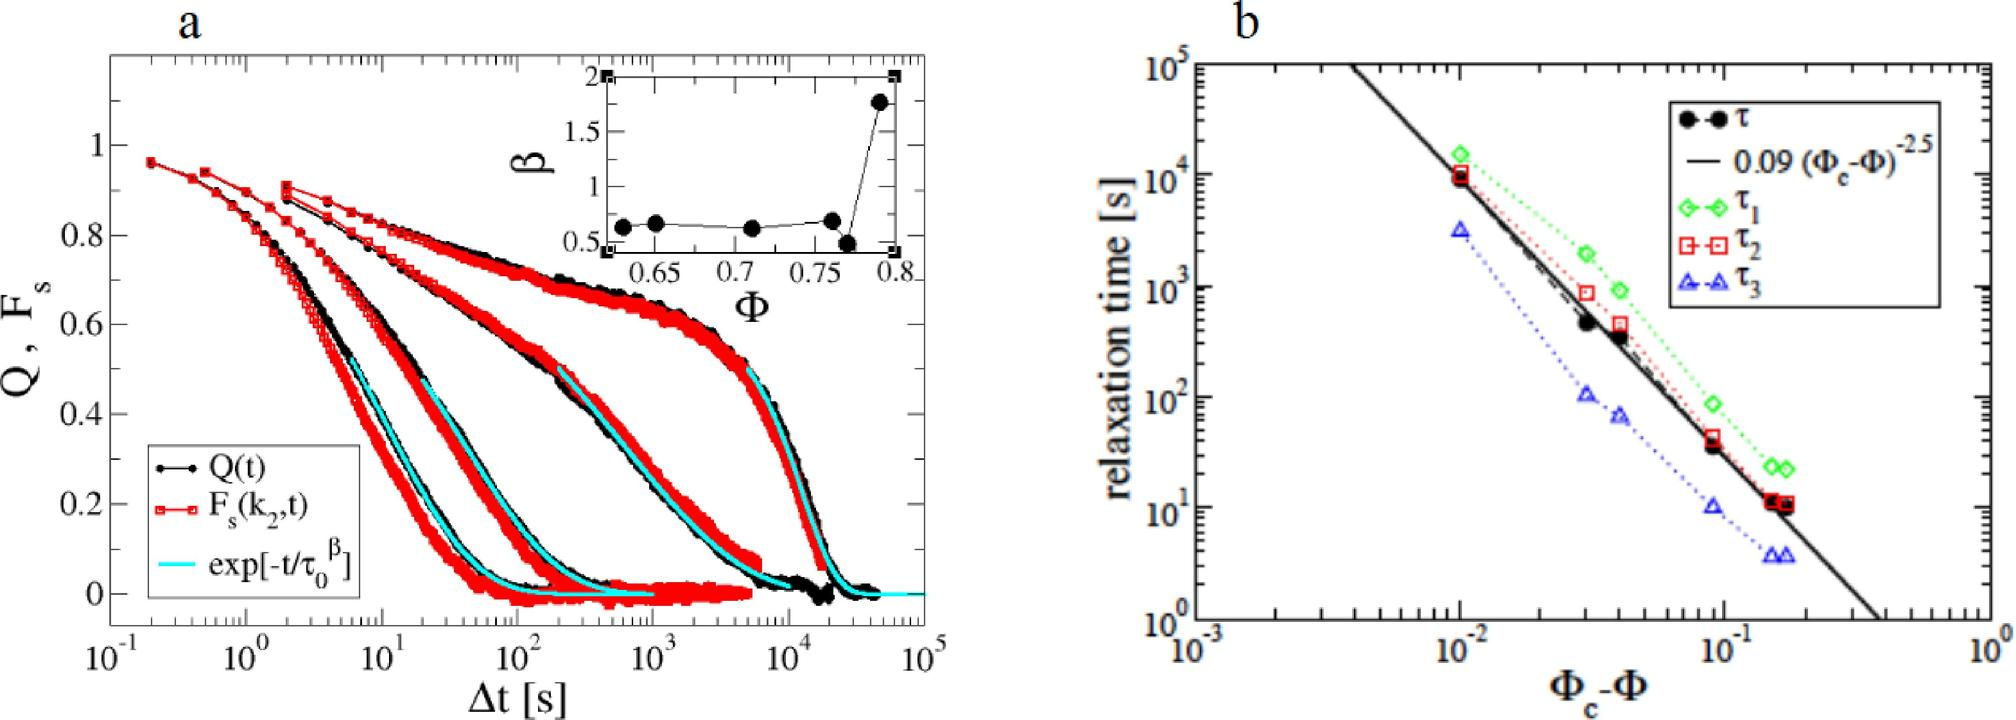In figure b, what does the dashed line represent? A. A fit of the relaxation time with respect to (
 - 
_c B. The raw data of relaxation time for
 C. The theoretical prediction for 
 D. A baseline for the relaxation times , 
, and The dashed line in figure b is indeed a mathematical representation, specifically being a plot of the equation '0.09 (
 - 
_c)^-2.5'. This equation outlines how relaxation time (
) varies with the difference (
 - 
_c), which is the gap from a critical parameter (
_c). Such fits are crucial in material science for understanding how close a system is to critical transitions, potentially affecting its mechanical properties. Therefore, the correct interpretation of the dashed line is A - a fit of relaxation times based on changes in property (
). 